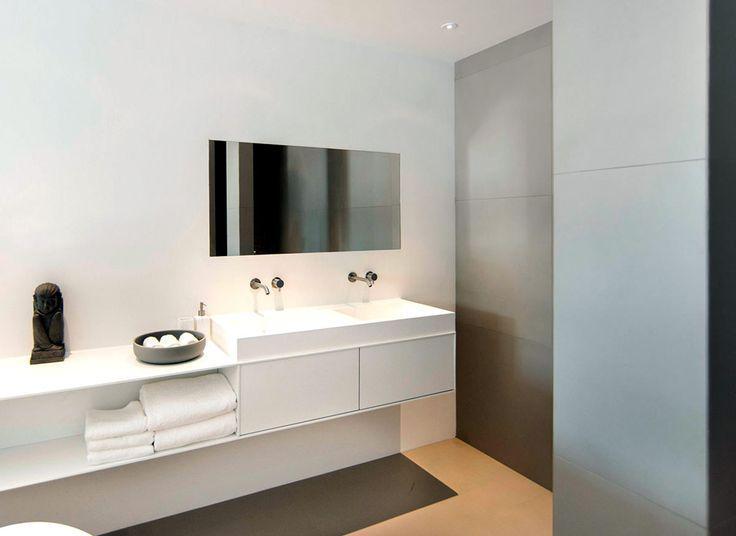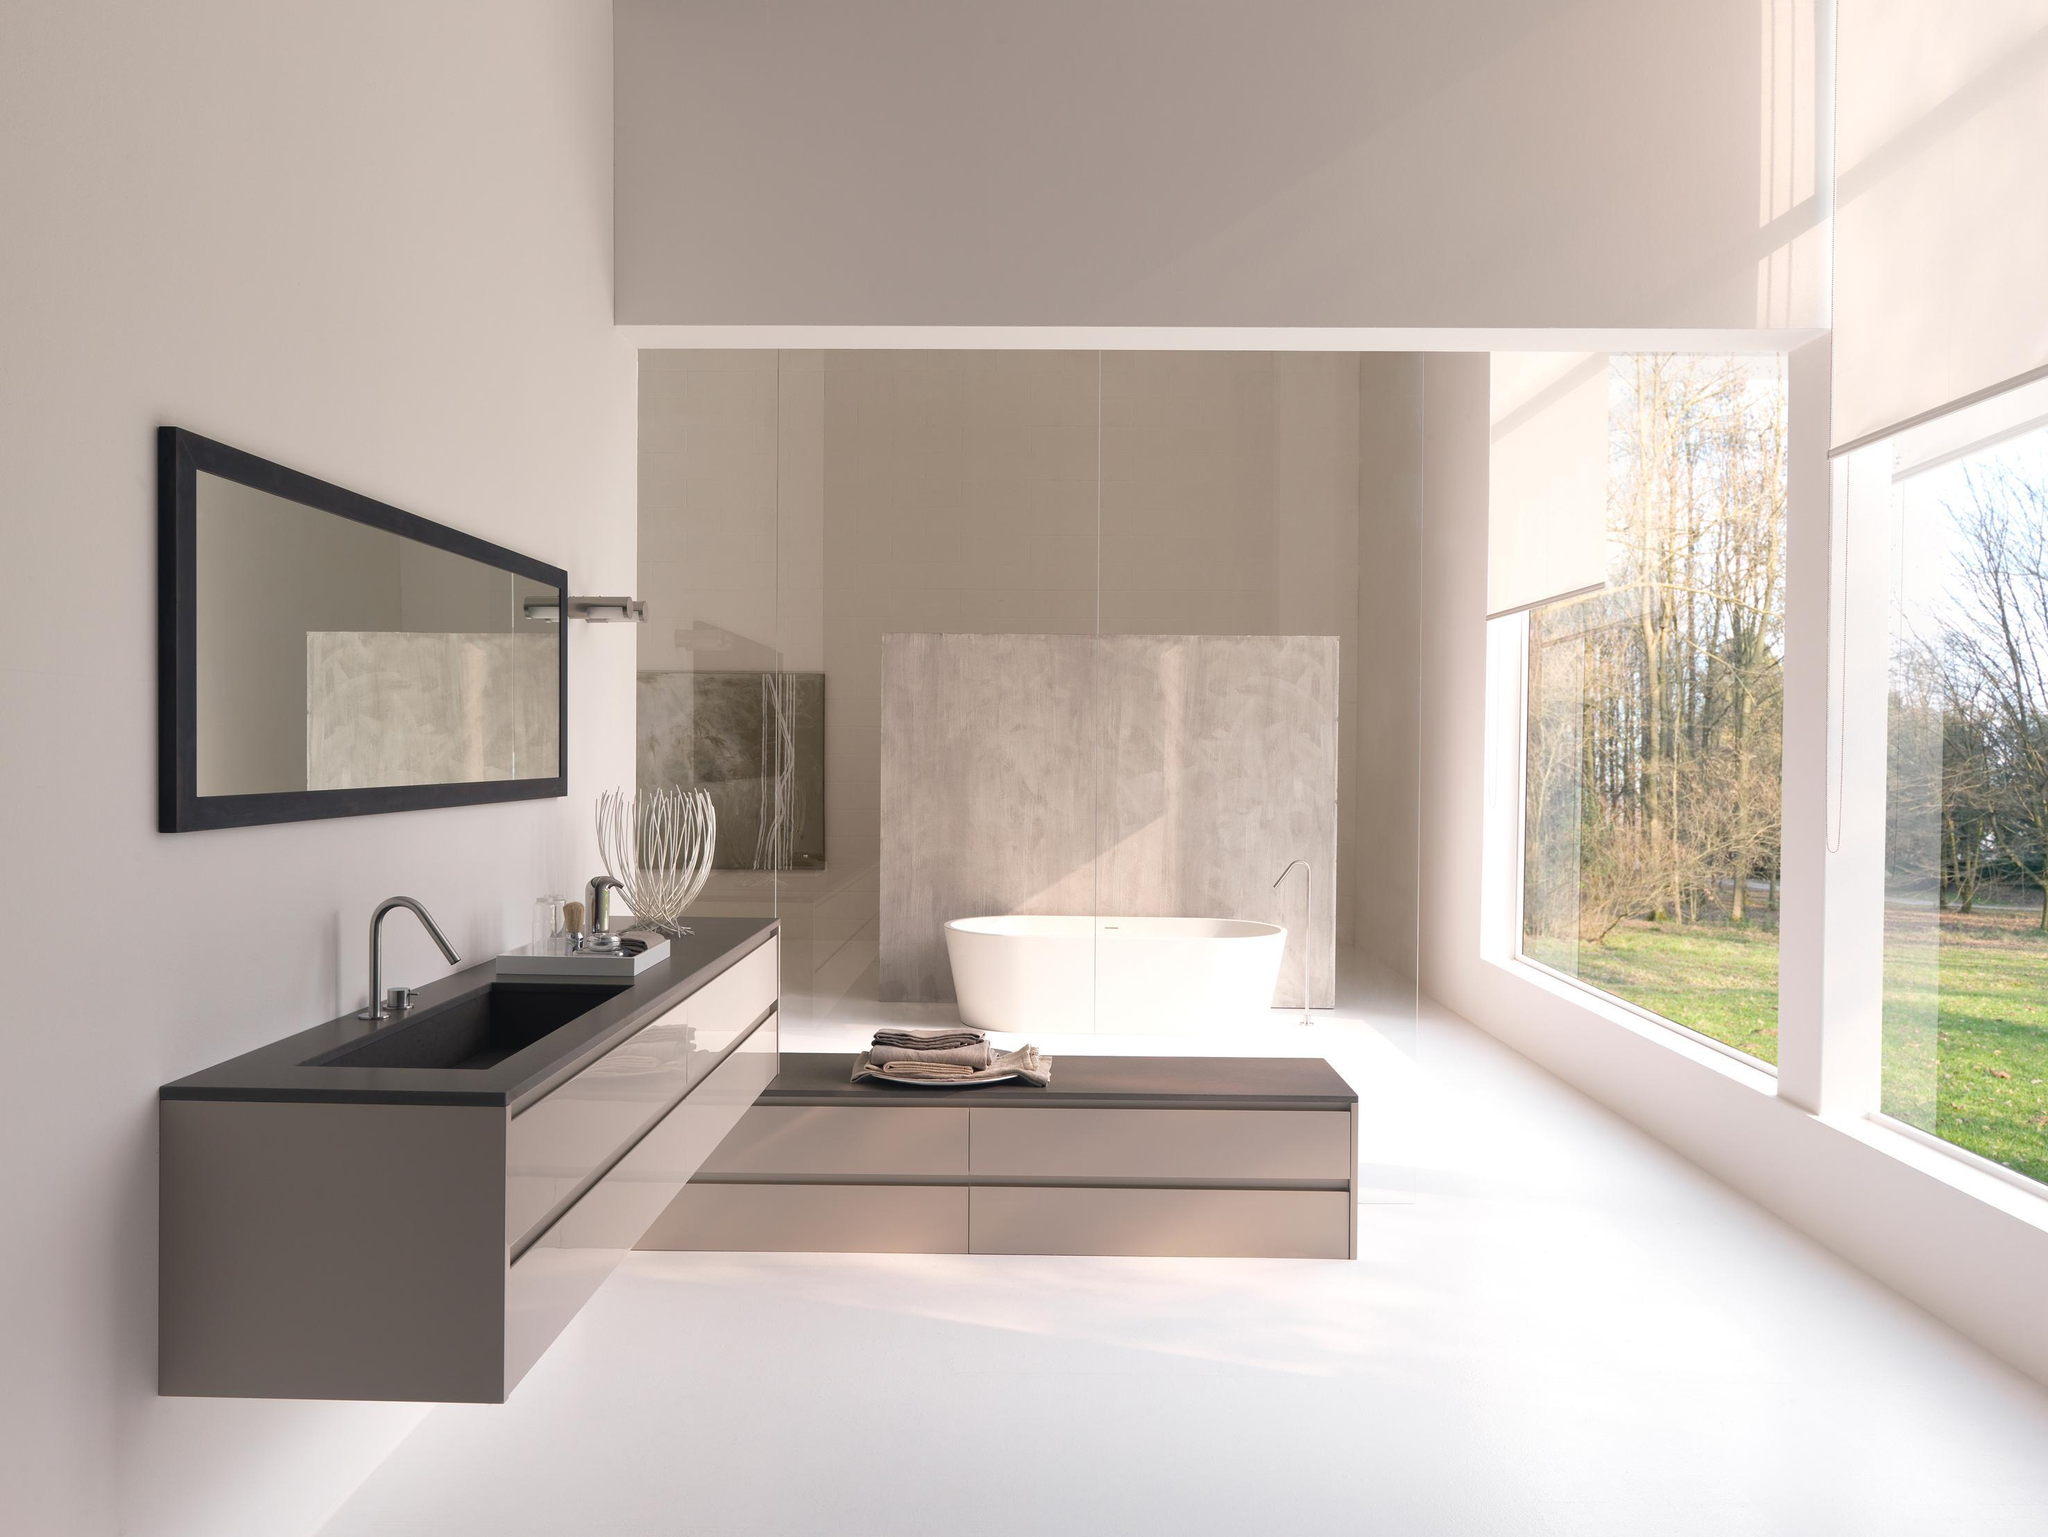The first image is the image on the left, the second image is the image on the right. Considering the images on both sides, is "A sink is in the shape of a cup." valid? Answer yes or no. No. 